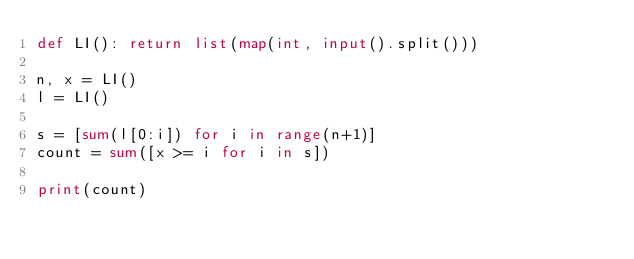<code> <loc_0><loc_0><loc_500><loc_500><_Python_>def LI(): return list(map(int, input().split()))

n, x = LI()
l = LI()

s = [sum(l[0:i]) for i in range(n+1)]
count = sum([x >= i for i in s])

print(count)
</code> 